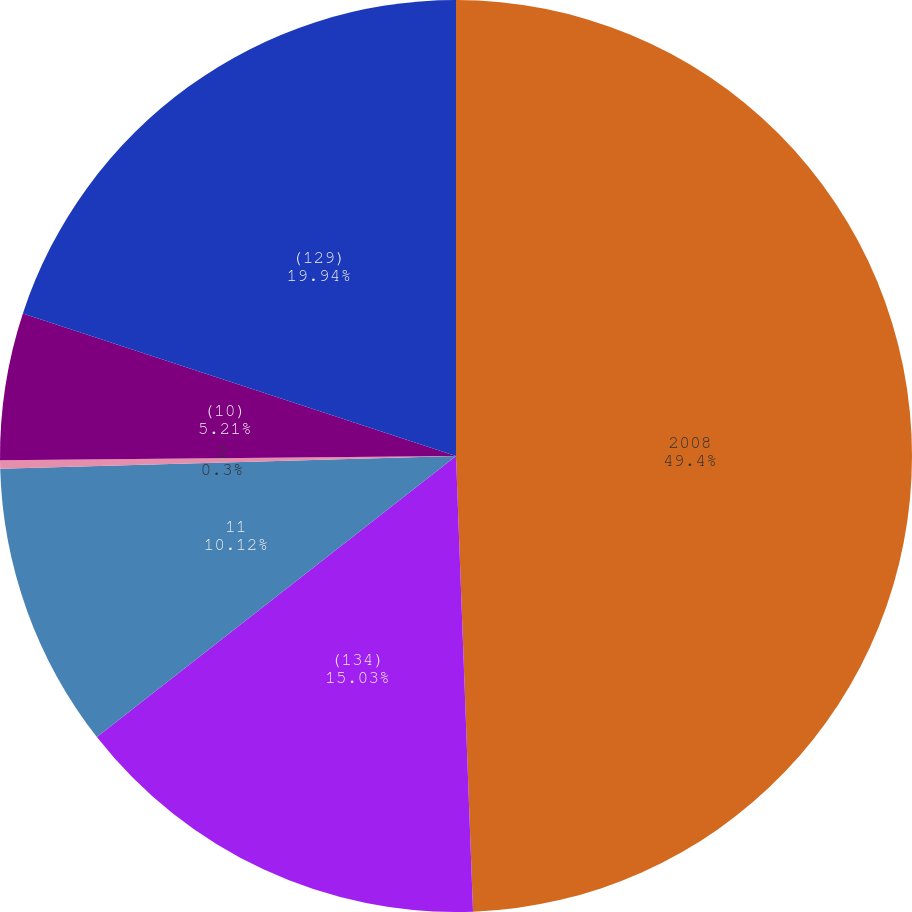<chart> <loc_0><loc_0><loc_500><loc_500><pie_chart><fcel>2008<fcel>(134)<fcel>11<fcel>2<fcel>(10)<fcel>(129)<nl><fcel>49.41%<fcel>15.03%<fcel>10.12%<fcel>0.3%<fcel>5.21%<fcel>19.94%<nl></chart> 